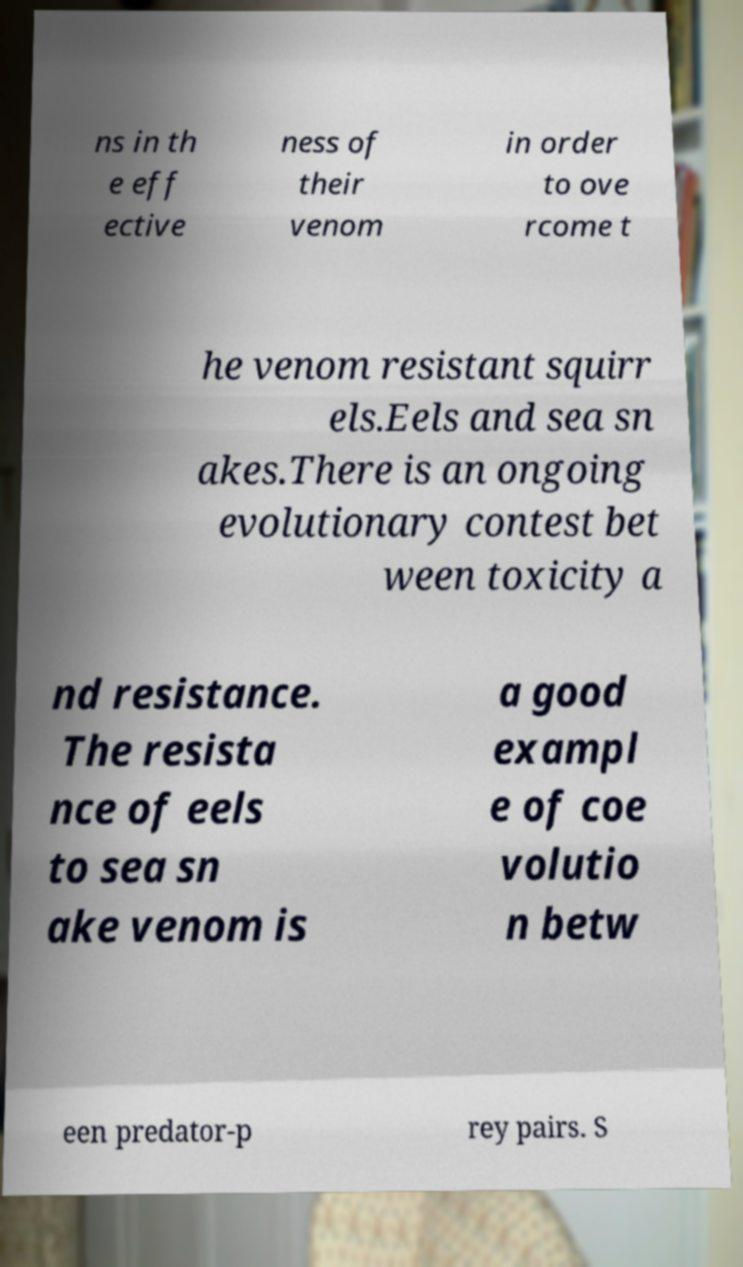Please read and relay the text visible in this image. What does it say? ns in th e eff ective ness of their venom in order to ove rcome t he venom resistant squirr els.Eels and sea sn akes.There is an ongoing evolutionary contest bet ween toxicity a nd resistance. The resista nce of eels to sea sn ake venom is a good exampl e of coe volutio n betw een predator-p rey pairs. S 